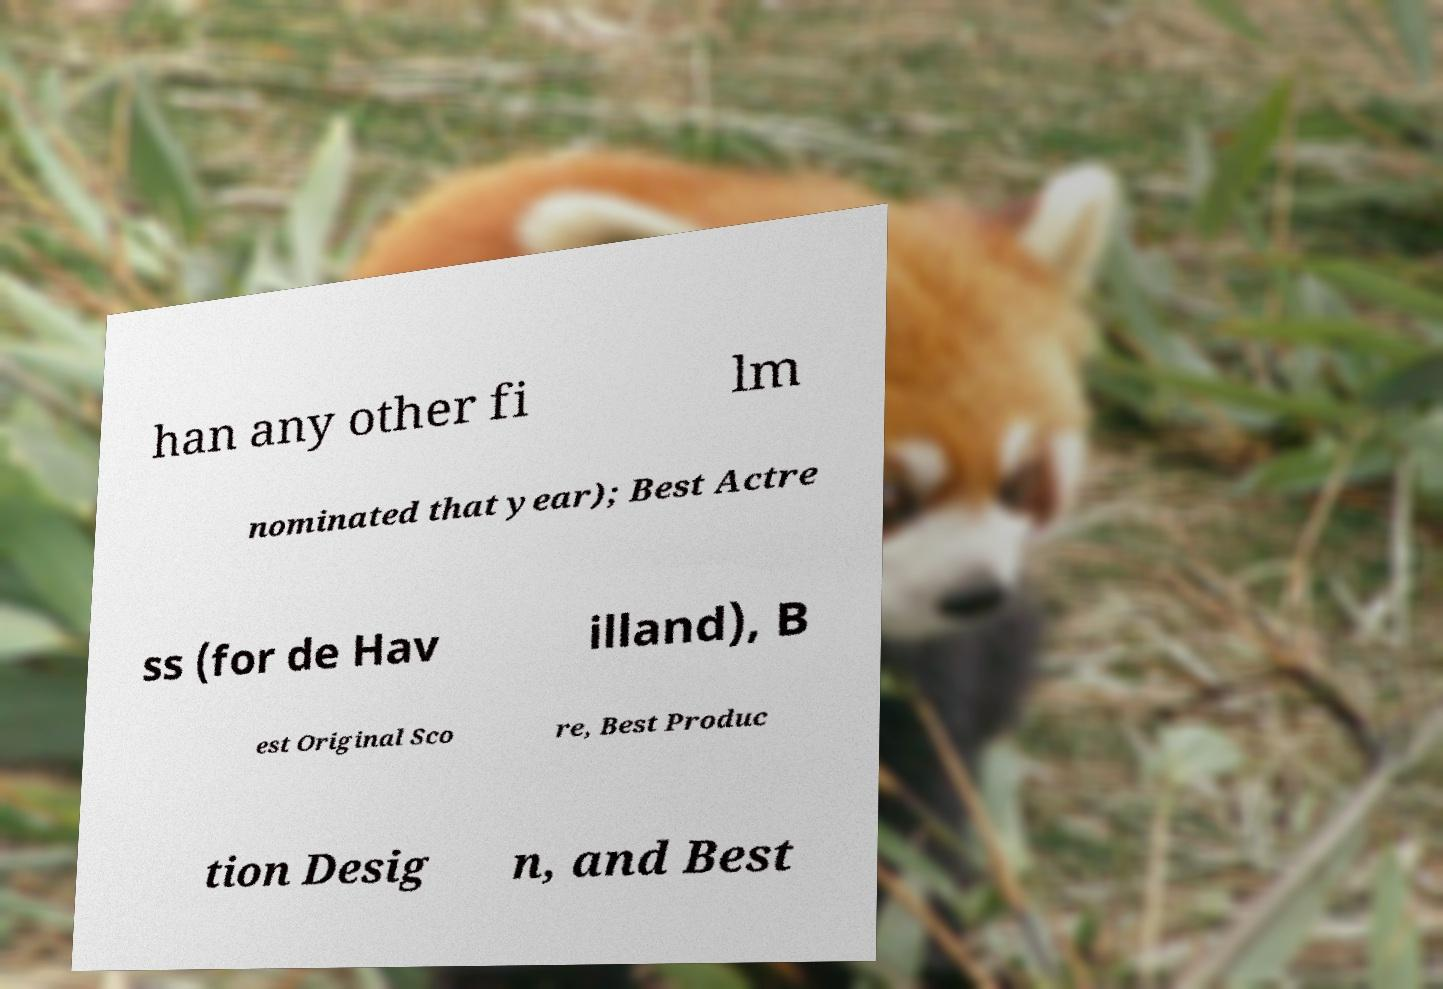There's text embedded in this image that I need extracted. Can you transcribe it verbatim? han any other fi lm nominated that year); Best Actre ss (for de Hav illand), B est Original Sco re, Best Produc tion Desig n, and Best 